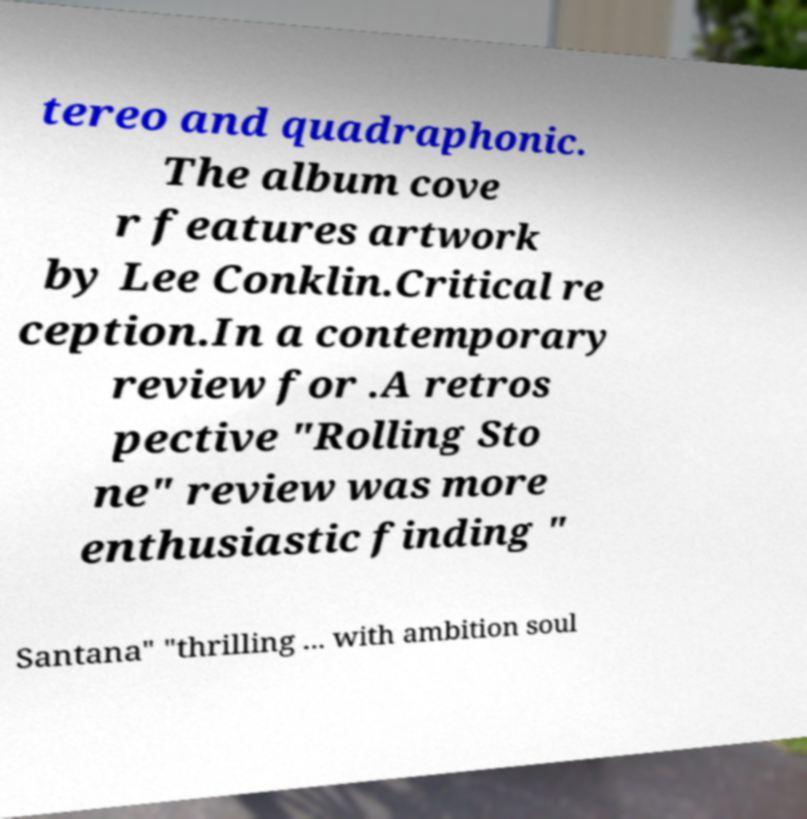Could you extract and type out the text from this image? tereo and quadraphonic. The album cove r features artwork by Lee Conklin.Critical re ception.In a contemporary review for .A retros pective "Rolling Sto ne" review was more enthusiastic finding " Santana" "thrilling ... with ambition soul 